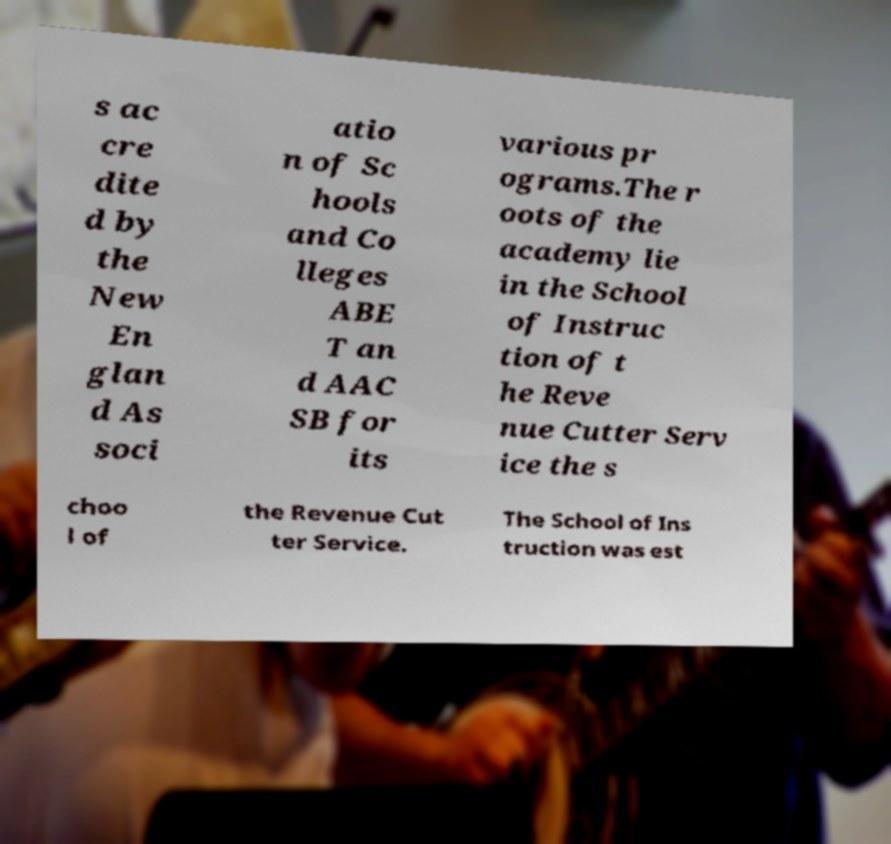What messages or text are displayed in this image? I need them in a readable, typed format. s ac cre dite d by the New En glan d As soci atio n of Sc hools and Co lleges ABE T an d AAC SB for its various pr ograms.The r oots of the academy lie in the School of Instruc tion of t he Reve nue Cutter Serv ice the s choo l of the Revenue Cut ter Service. The School of Ins truction was est 